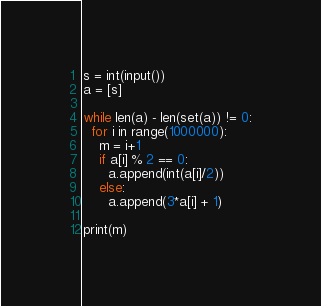<code> <loc_0><loc_0><loc_500><loc_500><_Python_>s = int(input())
a = [s]

while len(a) - len(set(a)) != 0:
  for i in range(1000000):
    m = i+1
    if a[i] % 2 == 0:
      a.append(int(a[i]/2))
    else:
      a.append(3*a[i] + 1)
      
print(m)</code> 